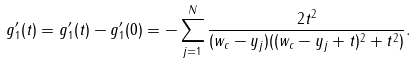Convert formula to latex. <formula><loc_0><loc_0><loc_500><loc_500>g _ { 1 } ^ { \prime } ( t ) = g _ { 1 } ^ { \prime } ( t ) - g _ { 1 } ^ { \prime } ( 0 ) = - \sum _ { j = 1 } ^ { N } \frac { 2 t ^ { 2 } } { ( w _ { c } - y _ { j } ) ( ( w _ { c } - y _ { j } + t ) ^ { 2 } + t ^ { 2 } ) } .</formula> 